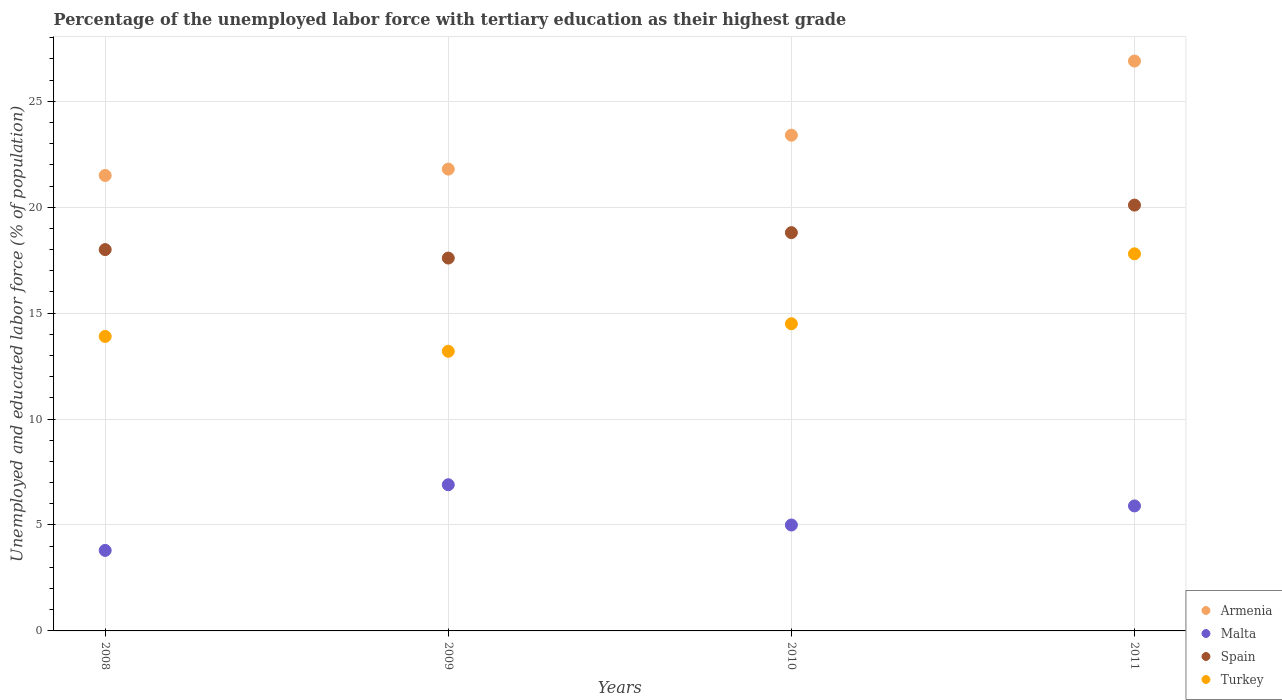How many different coloured dotlines are there?
Keep it short and to the point. 4. What is the percentage of the unemployed labor force with tertiary education in Spain in 2009?
Provide a short and direct response. 17.6. Across all years, what is the maximum percentage of the unemployed labor force with tertiary education in Armenia?
Your answer should be very brief. 26.9. Across all years, what is the minimum percentage of the unemployed labor force with tertiary education in Spain?
Your response must be concise. 17.6. In which year was the percentage of the unemployed labor force with tertiary education in Turkey maximum?
Your answer should be compact. 2011. What is the total percentage of the unemployed labor force with tertiary education in Malta in the graph?
Offer a terse response. 21.6. What is the difference between the percentage of the unemployed labor force with tertiary education in Turkey in 2010 and that in 2011?
Provide a short and direct response. -3.3. What is the difference between the percentage of the unemployed labor force with tertiary education in Spain in 2011 and the percentage of the unemployed labor force with tertiary education in Malta in 2009?
Ensure brevity in your answer.  13.2. What is the average percentage of the unemployed labor force with tertiary education in Spain per year?
Your response must be concise. 18.62. In the year 2009, what is the difference between the percentage of the unemployed labor force with tertiary education in Malta and percentage of the unemployed labor force with tertiary education in Armenia?
Your answer should be very brief. -14.9. What is the ratio of the percentage of the unemployed labor force with tertiary education in Malta in 2009 to that in 2010?
Offer a terse response. 1.38. What is the difference between the highest and the second highest percentage of the unemployed labor force with tertiary education in Turkey?
Offer a terse response. 3.3. What is the difference between the highest and the lowest percentage of the unemployed labor force with tertiary education in Spain?
Make the answer very short. 2.5. Is the sum of the percentage of the unemployed labor force with tertiary education in Malta in 2008 and 2010 greater than the maximum percentage of the unemployed labor force with tertiary education in Spain across all years?
Your answer should be compact. No. Is it the case that in every year, the sum of the percentage of the unemployed labor force with tertiary education in Turkey and percentage of the unemployed labor force with tertiary education in Spain  is greater than the percentage of the unemployed labor force with tertiary education in Malta?
Provide a succinct answer. Yes. Does the percentage of the unemployed labor force with tertiary education in Malta monotonically increase over the years?
Make the answer very short. No. Is the percentage of the unemployed labor force with tertiary education in Turkey strictly greater than the percentage of the unemployed labor force with tertiary education in Malta over the years?
Your response must be concise. Yes. Is the percentage of the unemployed labor force with tertiary education in Armenia strictly less than the percentage of the unemployed labor force with tertiary education in Malta over the years?
Offer a terse response. No. How many years are there in the graph?
Offer a very short reply. 4. Does the graph contain any zero values?
Ensure brevity in your answer.  No. Does the graph contain grids?
Give a very brief answer. Yes. Where does the legend appear in the graph?
Your answer should be compact. Bottom right. How many legend labels are there?
Give a very brief answer. 4. How are the legend labels stacked?
Provide a succinct answer. Vertical. What is the title of the graph?
Provide a succinct answer. Percentage of the unemployed labor force with tertiary education as their highest grade. What is the label or title of the Y-axis?
Your response must be concise. Unemployed and educated labor force (% of population). What is the Unemployed and educated labor force (% of population) of Malta in 2008?
Offer a terse response. 3.8. What is the Unemployed and educated labor force (% of population) in Spain in 2008?
Your answer should be very brief. 18. What is the Unemployed and educated labor force (% of population) in Turkey in 2008?
Your answer should be compact. 13.9. What is the Unemployed and educated labor force (% of population) of Armenia in 2009?
Your response must be concise. 21.8. What is the Unemployed and educated labor force (% of population) of Malta in 2009?
Keep it short and to the point. 6.9. What is the Unemployed and educated labor force (% of population) in Spain in 2009?
Provide a succinct answer. 17.6. What is the Unemployed and educated labor force (% of population) in Turkey in 2009?
Offer a terse response. 13.2. What is the Unemployed and educated labor force (% of population) in Armenia in 2010?
Offer a terse response. 23.4. What is the Unemployed and educated labor force (% of population) in Spain in 2010?
Your answer should be very brief. 18.8. What is the Unemployed and educated labor force (% of population) in Turkey in 2010?
Keep it short and to the point. 14.5. What is the Unemployed and educated labor force (% of population) of Armenia in 2011?
Your answer should be compact. 26.9. What is the Unemployed and educated labor force (% of population) of Malta in 2011?
Ensure brevity in your answer.  5.9. What is the Unemployed and educated labor force (% of population) in Spain in 2011?
Keep it short and to the point. 20.1. What is the Unemployed and educated labor force (% of population) in Turkey in 2011?
Make the answer very short. 17.8. Across all years, what is the maximum Unemployed and educated labor force (% of population) in Armenia?
Offer a very short reply. 26.9. Across all years, what is the maximum Unemployed and educated labor force (% of population) of Malta?
Ensure brevity in your answer.  6.9. Across all years, what is the maximum Unemployed and educated labor force (% of population) in Spain?
Keep it short and to the point. 20.1. Across all years, what is the maximum Unemployed and educated labor force (% of population) in Turkey?
Keep it short and to the point. 17.8. Across all years, what is the minimum Unemployed and educated labor force (% of population) of Armenia?
Give a very brief answer. 21.5. Across all years, what is the minimum Unemployed and educated labor force (% of population) of Malta?
Your answer should be compact. 3.8. Across all years, what is the minimum Unemployed and educated labor force (% of population) of Spain?
Provide a short and direct response. 17.6. Across all years, what is the minimum Unemployed and educated labor force (% of population) in Turkey?
Offer a terse response. 13.2. What is the total Unemployed and educated labor force (% of population) in Armenia in the graph?
Make the answer very short. 93.6. What is the total Unemployed and educated labor force (% of population) of Malta in the graph?
Offer a terse response. 21.6. What is the total Unemployed and educated labor force (% of population) in Spain in the graph?
Offer a terse response. 74.5. What is the total Unemployed and educated labor force (% of population) in Turkey in the graph?
Provide a succinct answer. 59.4. What is the difference between the Unemployed and educated labor force (% of population) of Armenia in 2008 and that in 2009?
Provide a short and direct response. -0.3. What is the difference between the Unemployed and educated labor force (% of population) of Spain in 2008 and that in 2009?
Ensure brevity in your answer.  0.4. What is the difference between the Unemployed and educated labor force (% of population) in Turkey in 2008 and that in 2009?
Make the answer very short. 0.7. What is the difference between the Unemployed and educated labor force (% of population) in Armenia in 2008 and that in 2011?
Give a very brief answer. -5.4. What is the difference between the Unemployed and educated labor force (% of population) of Spain in 2008 and that in 2011?
Give a very brief answer. -2.1. What is the difference between the Unemployed and educated labor force (% of population) of Malta in 2009 and that in 2010?
Your answer should be compact. 1.9. What is the difference between the Unemployed and educated labor force (% of population) in Armenia in 2009 and that in 2011?
Ensure brevity in your answer.  -5.1. What is the difference between the Unemployed and educated labor force (% of population) in Turkey in 2009 and that in 2011?
Ensure brevity in your answer.  -4.6. What is the difference between the Unemployed and educated labor force (% of population) of Armenia in 2010 and that in 2011?
Provide a short and direct response. -3.5. What is the difference between the Unemployed and educated labor force (% of population) in Malta in 2010 and that in 2011?
Ensure brevity in your answer.  -0.9. What is the difference between the Unemployed and educated labor force (% of population) in Spain in 2010 and that in 2011?
Your answer should be compact. -1.3. What is the difference between the Unemployed and educated labor force (% of population) of Turkey in 2010 and that in 2011?
Offer a terse response. -3.3. What is the difference between the Unemployed and educated labor force (% of population) in Armenia in 2008 and the Unemployed and educated labor force (% of population) in Spain in 2009?
Your response must be concise. 3.9. What is the difference between the Unemployed and educated labor force (% of population) of Malta in 2008 and the Unemployed and educated labor force (% of population) of Spain in 2009?
Keep it short and to the point. -13.8. What is the difference between the Unemployed and educated labor force (% of population) in Armenia in 2008 and the Unemployed and educated labor force (% of population) in Malta in 2010?
Your answer should be very brief. 16.5. What is the difference between the Unemployed and educated labor force (% of population) in Armenia in 2008 and the Unemployed and educated labor force (% of population) in Turkey in 2010?
Make the answer very short. 7. What is the difference between the Unemployed and educated labor force (% of population) of Malta in 2008 and the Unemployed and educated labor force (% of population) of Spain in 2010?
Ensure brevity in your answer.  -15. What is the difference between the Unemployed and educated labor force (% of population) of Malta in 2008 and the Unemployed and educated labor force (% of population) of Turkey in 2010?
Make the answer very short. -10.7. What is the difference between the Unemployed and educated labor force (% of population) of Spain in 2008 and the Unemployed and educated labor force (% of population) of Turkey in 2010?
Provide a succinct answer. 3.5. What is the difference between the Unemployed and educated labor force (% of population) in Armenia in 2008 and the Unemployed and educated labor force (% of population) in Malta in 2011?
Keep it short and to the point. 15.6. What is the difference between the Unemployed and educated labor force (% of population) in Malta in 2008 and the Unemployed and educated labor force (% of population) in Spain in 2011?
Provide a succinct answer. -16.3. What is the difference between the Unemployed and educated labor force (% of population) of Malta in 2008 and the Unemployed and educated labor force (% of population) of Turkey in 2011?
Your response must be concise. -14. What is the difference between the Unemployed and educated labor force (% of population) in Armenia in 2009 and the Unemployed and educated labor force (% of population) in Spain in 2010?
Provide a succinct answer. 3. What is the difference between the Unemployed and educated labor force (% of population) of Armenia in 2009 and the Unemployed and educated labor force (% of population) of Turkey in 2010?
Your answer should be very brief. 7.3. What is the difference between the Unemployed and educated labor force (% of population) in Malta in 2009 and the Unemployed and educated labor force (% of population) in Spain in 2010?
Offer a terse response. -11.9. What is the difference between the Unemployed and educated labor force (% of population) in Malta in 2009 and the Unemployed and educated labor force (% of population) in Turkey in 2010?
Provide a short and direct response. -7.6. What is the difference between the Unemployed and educated labor force (% of population) of Armenia in 2009 and the Unemployed and educated labor force (% of population) of Spain in 2011?
Keep it short and to the point. 1.7. What is the difference between the Unemployed and educated labor force (% of population) in Malta in 2009 and the Unemployed and educated labor force (% of population) in Spain in 2011?
Provide a short and direct response. -13.2. What is the difference between the Unemployed and educated labor force (% of population) of Malta in 2009 and the Unemployed and educated labor force (% of population) of Turkey in 2011?
Offer a terse response. -10.9. What is the difference between the Unemployed and educated labor force (% of population) in Spain in 2009 and the Unemployed and educated labor force (% of population) in Turkey in 2011?
Make the answer very short. -0.2. What is the difference between the Unemployed and educated labor force (% of population) of Armenia in 2010 and the Unemployed and educated labor force (% of population) of Malta in 2011?
Your answer should be compact. 17.5. What is the difference between the Unemployed and educated labor force (% of population) in Armenia in 2010 and the Unemployed and educated labor force (% of population) in Spain in 2011?
Your answer should be compact. 3.3. What is the difference between the Unemployed and educated labor force (% of population) in Armenia in 2010 and the Unemployed and educated labor force (% of population) in Turkey in 2011?
Provide a succinct answer. 5.6. What is the difference between the Unemployed and educated labor force (% of population) in Malta in 2010 and the Unemployed and educated labor force (% of population) in Spain in 2011?
Provide a succinct answer. -15.1. What is the difference between the Unemployed and educated labor force (% of population) of Malta in 2010 and the Unemployed and educated labor force (% of population) of Turkey in 2011?
Offer a very short reply. -12.8. What is the average Unemployed and educated labor force (% of population) in Armenia per year?
Make the answer very short. 23.4. What is the average Unemployed and educated labor force (% of population) of Malta per year?
Provide a succinct answer. 5.4. What is the average Unemployed and educated labor force (% of population) in Spain per year?
Give a very brief answer. 18.62. What is the average Unemployed and educated labor force (% of population) of Turkey per year?
Keep it short and to the point. 14.85. In the year 2008, what is the difference between the Unemployed and educated labor force (% of population) in Armenia and Unemployed and educated labor force (% of population) in Malta?
Make the answer very short. 17.7. In the year 2008, what is the difference between the Unemployed and educated labor force (% of population) of Malta and Unemployed and educated labor force (% of population) of Spain?
Offer a very short reply. -14.2. In the year 2009, what is the difference between the Unemployed and educated labor force (% of population) in Armenia and Unemployed and educated labor force (% of population) in Spain?
Offer a very short reply. 4.2. In the year 2009, what is the difference between the Unemployed and educated labor force (% of population) of Armenia and Unemployed and educated labor force (% of population) of Turkey?
Your response must be concise. 8.6. In the year 2009, what is the difference between the Unemployed and educated labor force (% of population) in Malta and Unemployed and educated labor force (% of population) in Turkey?
Offer a very short reply. -6.3. In the year 2010, what is the difference between the Unemployed and educated labor force (% of population) of Malta and Unemployed and educated labor force (% of population) of Spain?
Give a very brief answer. -13.8. In the year 2011, what is the difference between the Unemployed and educated labor force (% of population) of Malta and Unemployed and educated labor force (% of population) of Spain?
Provide a short and direct response. -14.2. In the year 2011, what is the difference between the Unemployed and educated labor force (% of population) in Spain and Unemployed and educated labor force (% of population) in Turkey?
Keep it short and to the point. 2.3. What is the ratio of the Unemployed and educated labor force (% of population) in Armenia in 2008 to that in 2009?
Your answer should be very brief. 0.99. What is the ratio of the Unemployed and educated labor force (% of population) in Malta in 2008 to that in 2009?
Give a very brief answer. 0.55. What is the ratio of the Unemployed and educated labor force (% of population) of Spain in 2008 to that in 2009?
Provide a short and direct response. 1.02. What is the ratio of the Unemployed and educated labor force (% of population) of Turkey in 2008 to that in 2009?
Keep it short and to the point. 1.05. What is the ratio of the Unemployed and educated labor force (% of population) of Armenia in 2008 to that in 2010?
Your response must be concise. 0.92. What is the ratio of the Unemployed and educated labor force (% of population) of Malta in 2008 to that in 2010?
Give a very brief answer. 0.76. What is the ratio of the Unemployed and educated labor force (% of population) in Spain in 2008 to that in 2010?
Give a very brief answer. 0.96. What is the ratio of the Unemployed and educated labor force (% of population) of Turkey in 2008 to that in 2010?
Your answer should be compact. 0.96. What is the ratio of the Unemployed and educated labor force (% of population) of Armenia in 2008 to that in 2011?
Offer a very short reply. 0.8. What is the ratio of the Unemployed and educated labor force (% of population) in Malta in 2008 to that in 2011?
Offer a very short reply. 0.64. What is the ratio of the Unemployed and educated labor force (% of population) in Spain in 2008 to that in 2011?
Make the answer very short. 0.9. What is the ratio of the Unemployed and educated labor force (% of population) in Turkey in 2008 to that in 2011?
Make the answer very short. 0.78. What is the ratio of the Unemployed and educated labor force (% of population) of Armenia in 2009 to that in 2010?
Offer a very short reply. 0.93. What is the ratio of the Unemployed and educated labor force (% of population) of Malta in 2009 to that in 2010?
Your response must be concise. 1.38. What is the ratio of the Unemployed and educated labor force (% of population) of Spain in 2009 to that in 2010?
Offer a very short reply. 0.94. What is the ratio of the Unemployed and educated labor force (% of population) of Turkey in 2009 to that in 2010?
Make the answer very short. 0.91. What is the ratio of the Unemployed and educated labor force (% of population) in Armenia in 2009 to that in 2011?
Offer a terse response. 0.81. What is the ratio of the Unemployed and educated labor force (% of population) in Malta in 2009 to that in 2011?
Your answer should be very brief. 1.17. What is the ratio of the Unemployed and educated labor force (% of population) of Spain in 2009 to that in 2011?
Provide a succinct answer. 0.88. What is the ratio of the Unemployed and educated labor force (% of population) in Turkey in 2009 to that in 2011?
Your answer should be compact. 0.74. What is the ratio of the Unemployed and educated labor force (% of population) of Armenia in 2010 to that in 2011?
Offer a terse response. 0.87. What is the ratio of the Unemployed and educated labor force (% of population) in Malta in 2010 to that in 2011?
Make the answer very short. 0.85. What is the ratio of the Unemployed and educated labor force (% of population) of Spain in 2010 to that in 2011?
Give a very brief answer. 0.94. What is the ratio of the Unemployed and educated labor force (% of population) of Turkey in 2010 to that in 2011?
Provide a short and direct response. 0.81. What is the difference between the highest and the second highest Unemployed and educated labor force (% of population) in Turkey?
Your answer should be very brief. 3.3. What is the difference between the highest and the lowest Unemployed and educated labor force (% of population) in Armenia?
Your answer should be very brief. 5.4. What is the difference between the highest and the lowest Unemployed and educated labor force (% of population) of Malta?
Your answer should be compact. 3.1. What is the difference between the highest and the lowest Unemployed and educated labor force (% of population) in Spain?
Your answer should be very brief. 2.5. What is the difference between the highest and the lowest Unemployed and educated labor force (% of population) of Turkey?
Provide a succinct answer. 4.6. 